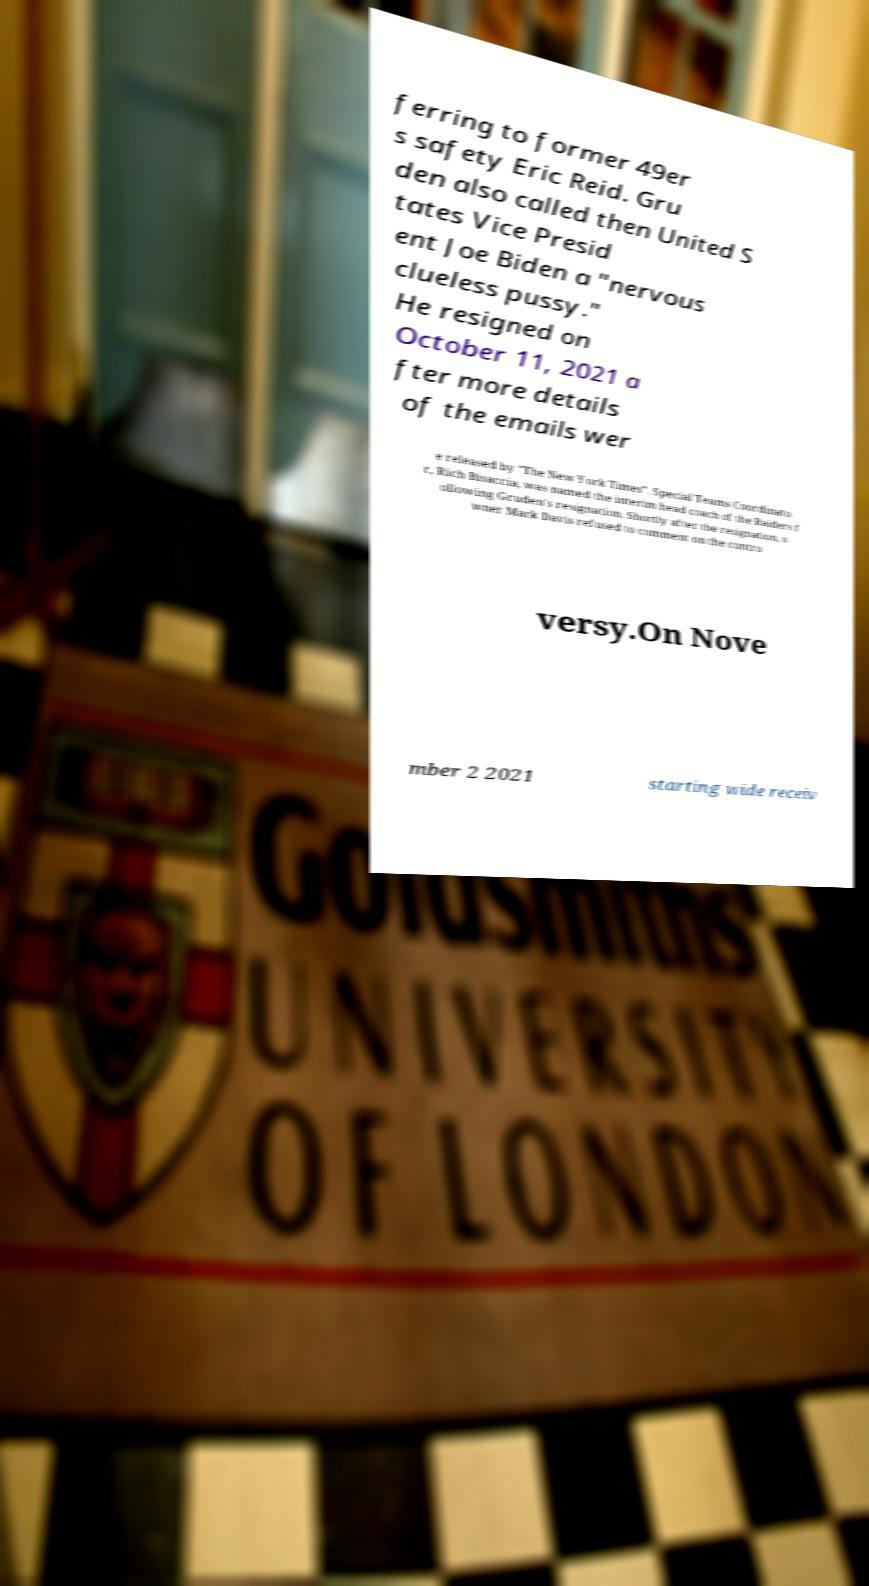What messages or text are displayed in this image? I need them in a readable, typed format. ferring to former 49er s safety Eric Reid. Gru den also called then United S tates Vice Presid ent Joe Biden a "nervous clueless pussy." He resigned on October 11, 2021 a fter more details of the emails wer e released by "The New York Times". Special Teams Coordinato r, Rich Bisaccia, was named the interim head coach of the Raiders f ollowing Gruden's resignation. Shortly after the resignation, o wner Mark Davis refused to comment on the contro versy.On Nove mber 2 2021 starting wide receiv 